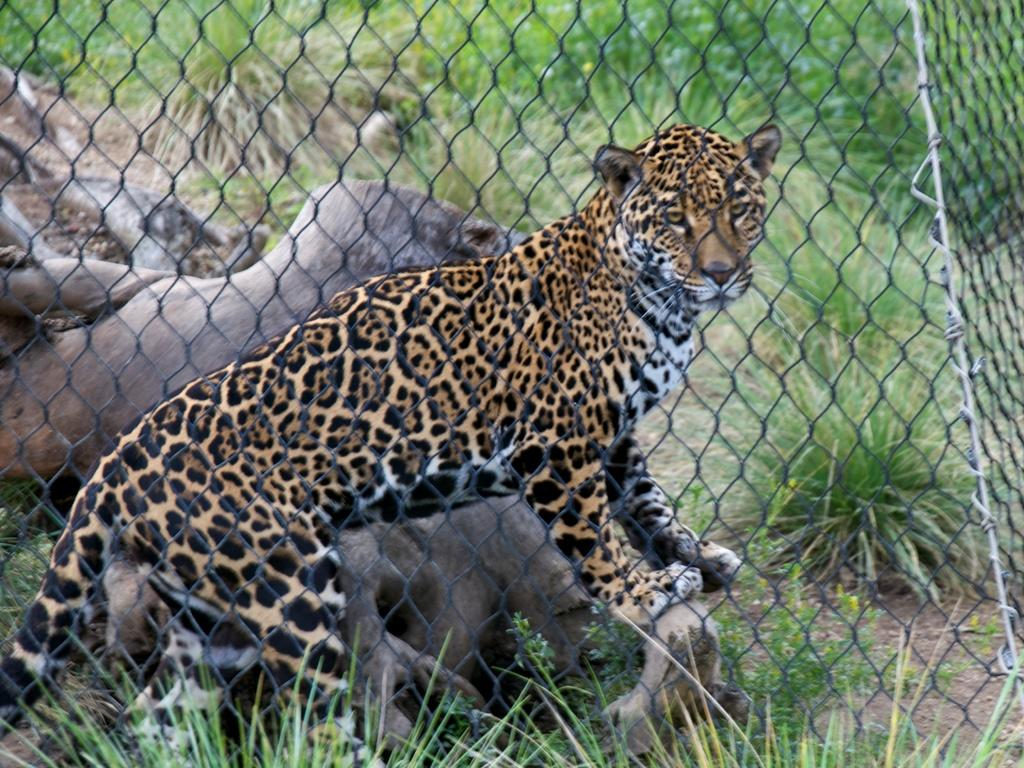What type of animal is in the image? There is a tiger in the image. What is separating the tiger from the viewer? The tiger is behind a fence. What can be seen in the background of the image? There are trees behind the fence. What is the ground surface like in the image? There is mud visible at the bottom of the image. What type of pest is visible in the image? There is no pest visible in the image; it features a tiger behind a fence with trees in the background and mud at the bottom. What religious symbol can be seen in the image? There is no religious symbol present in the image. 